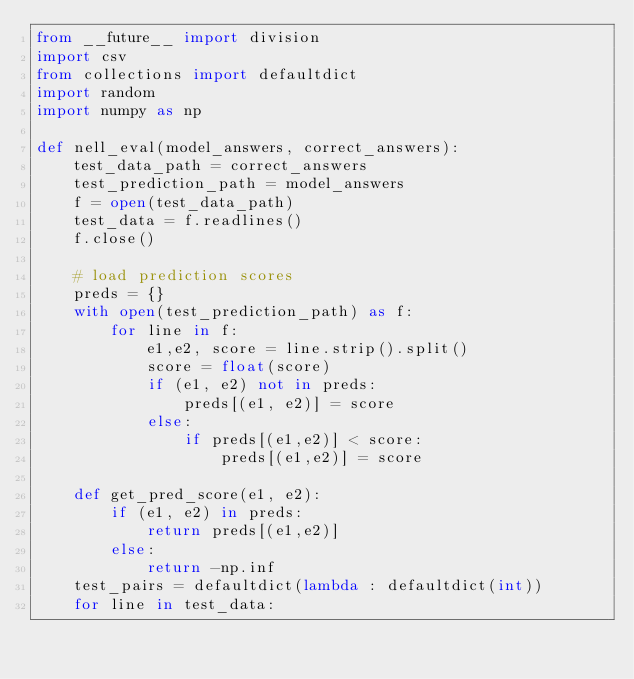<code> <loc_0><loc_0><loc_500><loc_500><_Python_>from __future__ import division
import csv
from collections import defaultdict
import random
import numpy as np

def nell_eval(model_answers, correct_answers):
    test_data_path = correct_answers
    test_prediction_path = model_answers
    f = open(test_data_path)
    test_data = f.readlines()
    f.close()

    # load prediction scores
    preds = {}
    with open(test_prediction_path) as f:
        for line in f:
            e1,e2, score = line.strip().split()
            score = float(score)
            if (e1, e2) not in preds:
                preds[(e1, e2)] = score
            else:
                if preds[(e1,e2)] < score:
                    preds[(e1,e2)] = score

    def get_pred_score(e1, e2):
        if (e1, e2) in preds:
            return preds[(e1,e2)]
        else:
            return -np.inf
    test_pairs = defaultdict(lambda : defaultdict(int))
    for line in test_data:</code> 